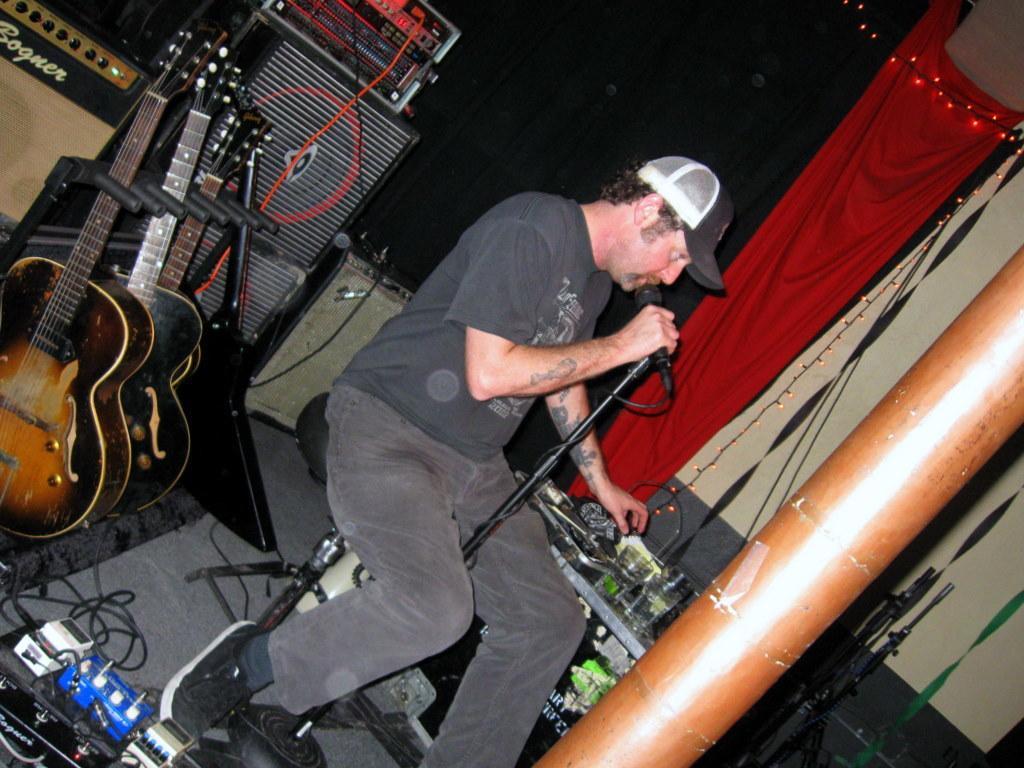Could you give a brief overview of what you see in this image? In the center of the image there is a man sitting on the chair. He is holding a mic in his hand maybe he is singing. On the left there are guitars and speaker. On the right there is a pillar. In the background there is a curtain and a wall. 